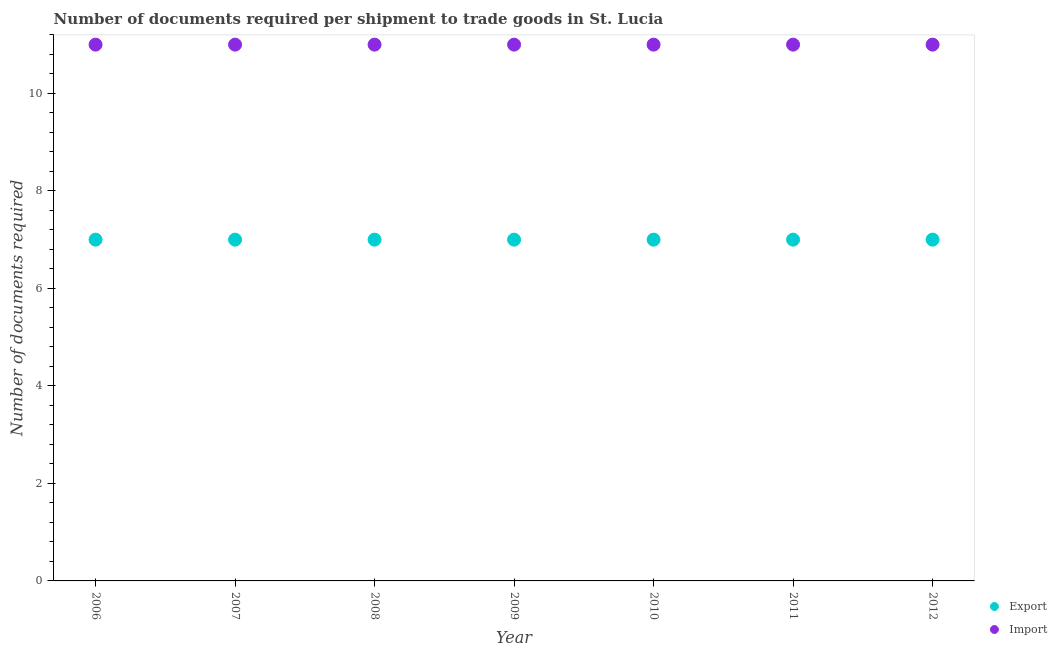How many different coloured dotlines are there?
Offer a terse response. 2. What is the number of documents required to export goods in 2008?
Ensure brevity in your answer.  7. Across all years, what is the maximum number of documents required to import goods?
Make the answer very short. 11. Across all years, what is the minimum number of documents required to import goods?
Provide a succinct answer. 11. In which year was the number of documents required to export goods maximum?
Offer a terse response. 2006. What is the total number of documents required to export goods in the graph?
Your answer should be compact. 49. What is the difference between the number of documents required to export goods in 2009 and that in 2012?
Give a very brief answer. 0. What is the difference between the number of documents required to export goods in 2011 and the number of documents required to import goods in 2010?
Provide a short and direct response. -4. What is the average number of documents required to import goods per year?
Offer a very short reply. 11. In the year 2006, what is the difference between the number of documents required to export goods and number of documents required to import goods?
Your response must be concise. -4. What is the ratio of the number of documents required to import goods in 2007 to that in 2012?
Give a very brief answer. 1. Is the number of documents required to import goods in 2010 less than that in 2012?
Keep it short and to the point. No. What is the difference between the highest and the second highest number of documents required to import goods?
Provide a short and direct response. 0. What is the difference between the highest and the lowest number of documents required to export goods?
Offer a very short reply. 0. Is the sum of the number of documents required to import goods in 2010 and 2012 greater than the maximum number of documents required to export goods across all years?
Your response must be concise. Yes. Is the number of documents required to import goods strictly greater than the number of documents required to export goods over the years?
Provide a short and direct response. Yes. Is the number of documents required to import goods strictly less than the number of documents required to export goods over the years?
Ensure brevity in your answer.  No. How many years are there in the graph?
Give a very brief answer. 7. What is the difference between two consecutive major ticks on the Y-axis?
Make the answer very short. 2. Does the graph contain any zero values?
Provide a short and direct response. No. What is the title of the graph?
Provide a succinct answer. Number of documents required per shipment to trade goods in St. Lucia. What is the label or title of the X-axis?
Your response must be concise. Year. What is the label or title of the Y-axis?
Ensure brevity in your answer.  Number of documents required. What is the Number of documents required of Export in 2009?
Keep it short and to the point. 7. What is the Number of documents required in Export in 2010?
Provide a short and direct response. 7. What is the Number of documents required in Export in 2011?
Your answer should be compact. 7. What is the Number of documents required in Import in 2011?
Provide a succinct answer. 11. Across all years, what is the maximum Number of documents required in Export?
Ensure brevity in your answer.  7. Across all years, what is the maximum Number of documents required in Import?
Your answer should be compact. 11. What is the total Number of documents required of Import in the graph?
Give a very brief answer. 77. What is the difference between the Number of documents required of Import in 2006 and that in 2007?
Make the answer very short. 0. What is the difference between the Number of documents required in Export in 2006 and that in 2008?
Your response must be concise. 0. What is the difference between the Number of documents required of Import in 2006 and that in 2008?
Ensure brevity in your answer.  0. What is the difference between the Number of documents required in Import in 2006 and that in 2011?
Make the answer very short. 0. What is the difference between the Number of documents required in Export in 2006 and that in 2012?
Give a very brief answer. 0. What is the difference between the Number of documents required of Import in 2006 and that in 2012?
Offer a terse response. 0. What is the difference between the Number of documents required in Export in 2007 and that in 2008?
Give a very brief answer. 0. What is the difference between the Number of documents required of Import in 2007 and that in 2008?
Ensure brevity in your answer.  0. What is the difference between the Number of documents required of Export in 2007 and that in 2009?
Make the answer very short. 0. What is the difference between the Number of documents required of Import in 2007 and that in 2010?
Give a very brief answer. 0. What is the difference between the Number of documents required in Import in 2007 and that in 2011?
Ensure brevity in your answer.  0. What is the difference between the Number of documents required of Export in 2008 and that in 2012?
Provide a succinct answer. 0. What is the difference between the Number of documents required of Import in 2008 and that in 2012?
Offer a terse response. 0. What is the difference between the Number of documents required of Export in 2009 and that in 2010?
Make the answer very short. 0. What is the difference between the Number of documents required in Import in 2009 and that in 2012?
Give a very brief answer. 0. What is the difference between the Number of documents required of Export in 2010 and that in 2011?
Give a very brief answer. 0. What is the difference between the Number of documents required of Import in 2010 and that in 2011?
Make the answer very short. 0. What is the difference between the Number of documents required of Export in 2006 and the Number of documents required of Import in 2007?
Provide a short and direct response. -4. What is the difference between the Number of documents required of Export in 2006 and the Number of documents required of Import in 2008?
Give a very brief answer. -4. What is the difference between the Number of documents required in Export in 2006 and the Number of documents required in Import in 2009?
Your answer should be very brief. -4. What is the difference between the Number of documents required of Export in 2006 and the Number of documents required of Import in 2010?
Provide a succinct answer. -4. What is the difference between the Number of documents required in Export in 2006 and the Number of documents required in Import in 2012?
Your response must be concise. -4. What is the difference between the Number of documents required in Export in 2007 and the Number of documents required in Import in 2010?
Provide a short and direct response. -4. What is the difference between the Number of documents required in Export in 2008 and the Number of documents required in Import in 2011?
Provide a succinct answer. -4. What is the difference between the Number of documents required of Export in 2009 and the Number of documents required of Import in 2010?
Give a very brief answer. -4. What is the difference between the Number of documents required in Export in 2009 and the Number of documents required in Import in 2012?
Offer a terse response. -4. What is the difference between the Number of documents required of Export in 2010 and the Number of documents required of Import in 2011?
Provide a short and direct response. -4. What is the difference between the Number of documents required in Export in 2010 and the Number of documents required in Import in 2012?
Give a very brief answer. -4. In the year 2007, what is the difference between the Number of documents required of Export and Number of documents required of Import?
Your answer should be compact. -4. In the year 2012, what is the difference between the Number of documents required in Export and Number of documents required in Import?
Your response must be concise. -4. What is the ratio of the Number of documents required of Export in 2006 to that in 2008?
Your response must be concise. 1. What is the ratio of the Number of documents required in Export in 2006 to that in 2009?
Offer a very short reply. 1. What is the ratio of the Number of documents required in Import in 2006 to that in 2009?
Keep it short and to the point. 1. What is the ratio of the Number of documents required of Export in 2006 to that in 2010?
Keep it short and to the point. 1. What is the ratio of the Number of documents required in Import in 2006 to that in 2010?
Your response must be concise. 1. What is the ratio of the Number of documents required in Export in 2006 to that in 2011?
Make the answer very short. 1. What is the ratio of the Number of documents required of Import in 2006 to that in 2011?
Your answer should be compact. 1. What is the ratio of the Number of documents required of Export in 2006 to that in 2012?
Ensure brevity in your answer.  1. What is the ratio of the Number of documents required in Import in 2006 to that in 2012?
Offer a very short reply. 1. What is the ratio of the Number of documents required in Export in 2007 to that in 2008?
Your response must be concise. 1. What is the ratio of the Number of documents required of Import in 2007 to that in 2008?
Give a very brief answer. 1. What is the ratio of the Number of documents required of Export in 2007 to that in 2009?
Offer a terse response. 1. What is the ratio of the Number of documents required of Import in 2007 to that in 2009?
Offer a terse response. 1. What is the ratio of the Number of documents required of Export in 2007 to that in 2011?
Your answer should be very brief. 1. What is the ratio of the Number of documents required in Import in 2007 to that in 2012?
Offer a very short reply. 1. What is the ratio of the Number of documents required in Export in 2008 to that in 2009?
Give a very brief answer. 1. What is the ratio of the Number of documents required in Import in 2008 to that in 2009?
Keep it short and to the point. 1. What is the ratio of the Number of documents required in Export in 2008 to that in 2010?
Offer a very short reply. 1. What is the ratio of the Number of documents required of Export in 2008 to that in 2011?
Your response must be concise. 1. What is the ratio of the Number of documents required of Import in 2008 to that in 2011?
Offer a terse response. 1. What is the ratio of the Number of documents required in Export in 2008 to that in 2012?
Give a very brief answer. 1. What is the ratio of the Number of documents required in Import in 2009 to that in 2011?
Offer a very short reply. 1. What is the ratio of the Number of documents required of Export in 2009 to that in 2012?
Ensure brevity in your answer.  1. What is the ratio of the Number of documents required of Import in 2011 to that in 2012?
Your answer should be compact. 1. 